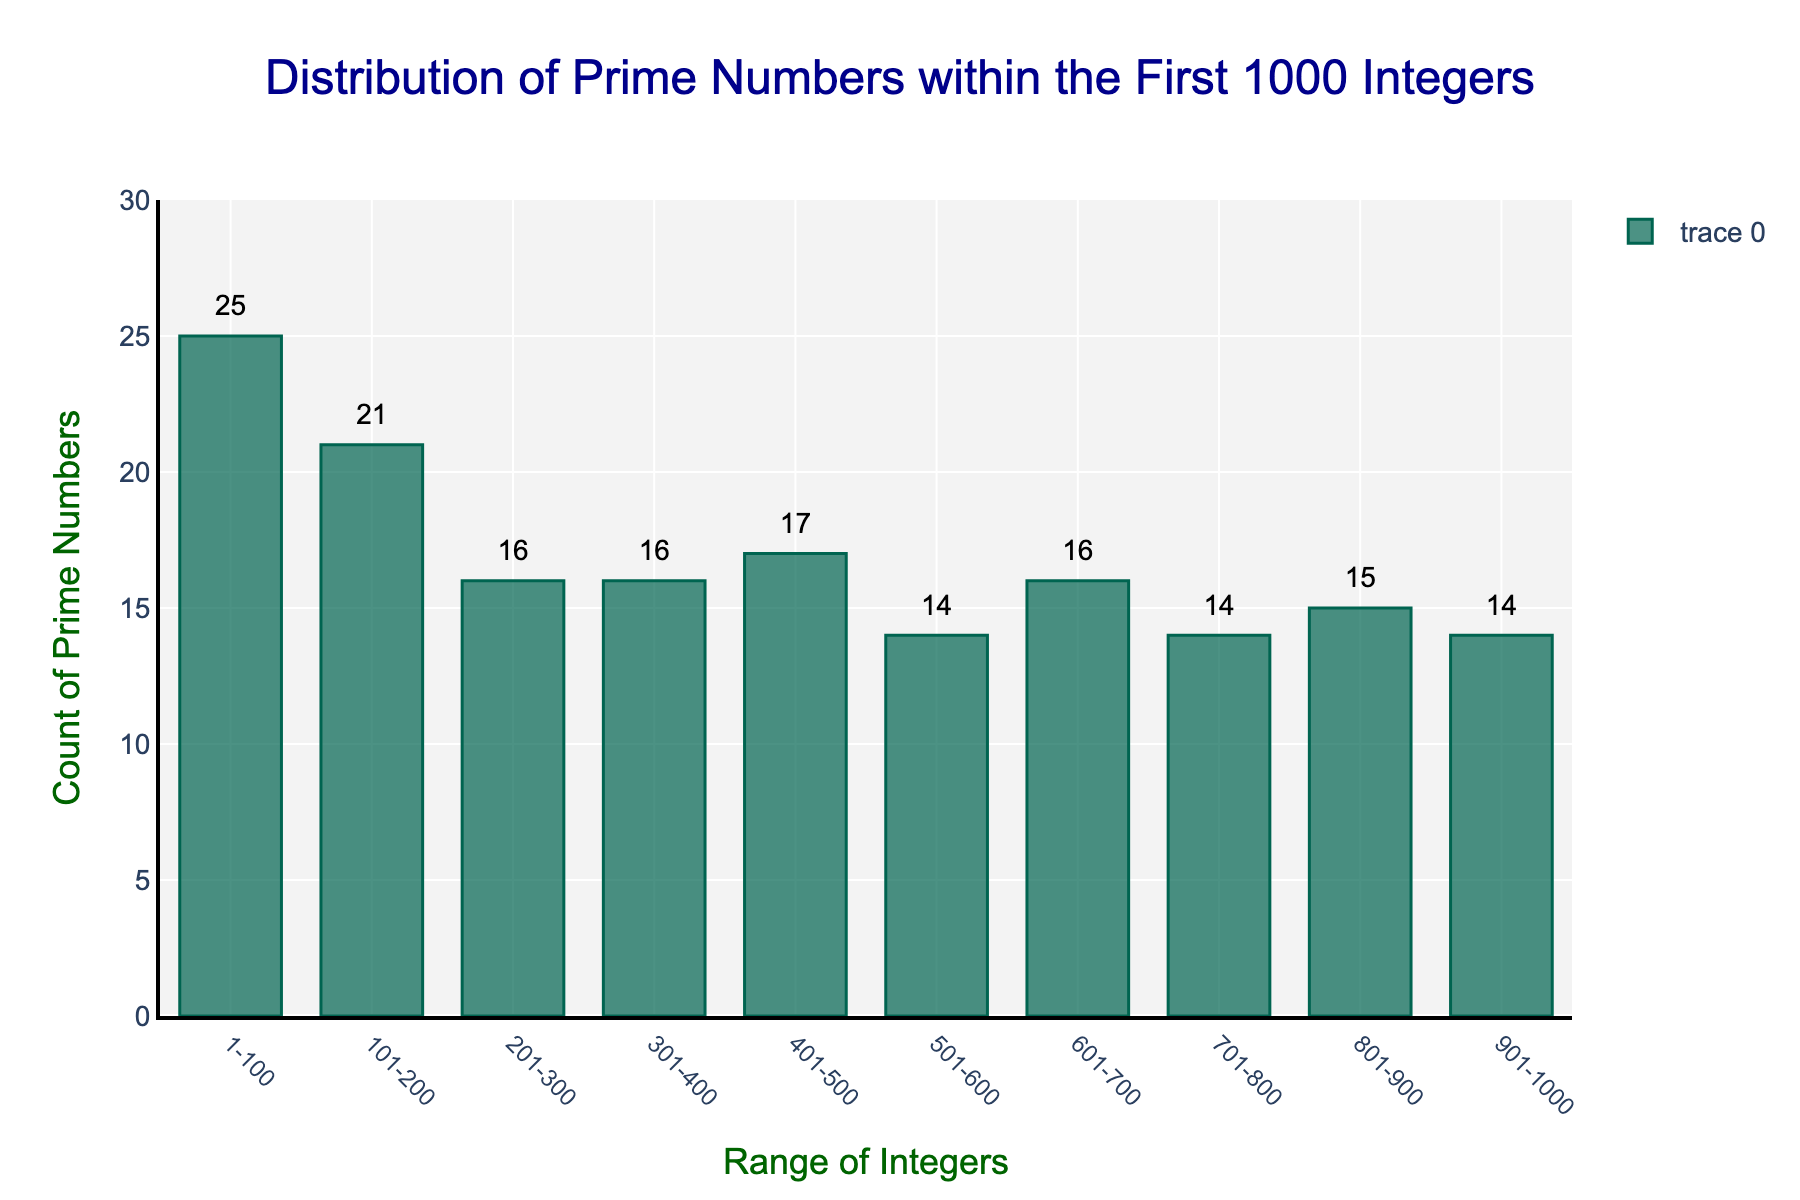How many prime numbers are there in the range 1-100? The bar corresponding to the range "1-100" has a count value of 25.
Answer: 25 Which range contains the fewest prime numbers? The bars corresponding to the ranges "501-600", "701-800", and "901-1000" each have a count value of 14; however, they share the smallest count.
Answer: 501-600, 701-800, 901-1000 How many prime numbers are there in the ranges 101-200 and 401-500 combined? The count in the range "101-200" is 21, and the count in the range "401-500" is 17. Adding them together gives 21 + 17 = 38.
Answer: 38 Which two consecutive ranges have the largest difference in the number of prime numbers? The differences between consecutive ranges are 4 (25-21), 5 (21-16), 0 (16-16), 1 (17-16), 3 (17-14), 2 (16-14), 1 (15-14), and 1 (14-13). The largest difference is 5, occurring between the ranges 101-200 and 201-300.
Answer: 101-200 and 201-300 Which range has more prime numbers: 401-500 or 301-400? The count for the range "401-500" is 17, while for "301-400" it is 16. 17 is greater than 16, so the range 401-500 has more prime numbers.
Answer: 401-500 What is the average number of prime numbers in each range? Sum all the counts (25+21+16+16+17+14+16+14+15+14=168), then divide by the number of ranges (10), which gives 168 / 10 = 16.8.
Answer: 16.8 Between which ranges do the number of prime numbers remain constant? By inspecting the counts, the number of prime numbers remains constant between the ranges "201-300" and "301-400" both having a count of 16.
Answer: 201-300 and 301-400 In which range is there a visible peak in the number of prime numbers? The highest point on the histogram corresponds to the range "1-100," which has the highest count of 25 prime numbers.
Answer: 1-100 